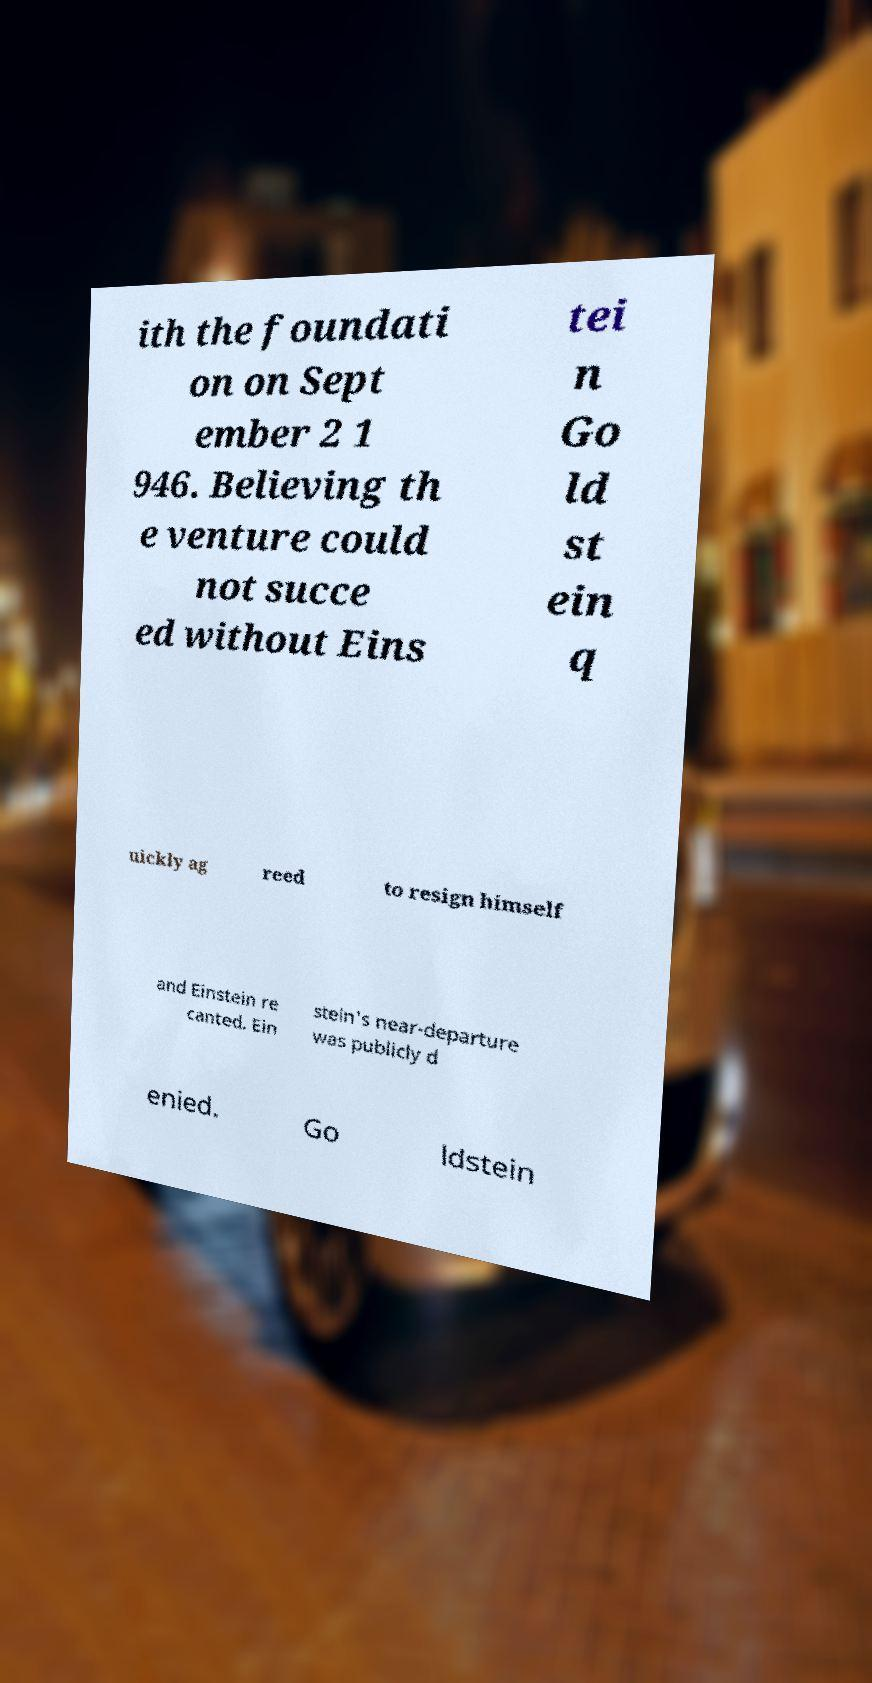I need the written content from this picture converted into text. Can you do that? ith the foundati on on Sept ember 2 1 946. Believing th e venture could not succe ed without Eins tei n Go ld st ein q uickly ag reed to resign himself and Einstein re canted. Ein stein's near-departure was publicly d enied. Go ldstein 